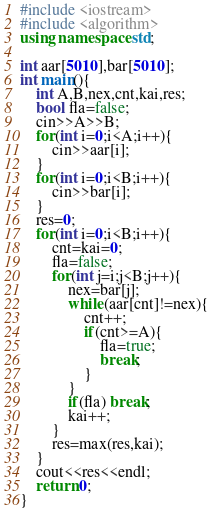Convert code to text. <code><loc_0><loc_0><loc_500><loc_500><_C++_>#include <iostream>
#include <algorithm>
using namespace std;

int aar[5010],bar[5010];
int main(){
	int A,B,nex,cnt,kai,res;
	bool fla=false;
	cin>>A>>B;
	for(int i=0;i<A;i++){
		cin>>aar[i];
	}
	for(int i=0;i<B;i++){
		cin>>bar[i];
	}
	res=0;
	for(int i=0;i<B;i++){
		cnt=kai=0;
		fla=false;
		for(int j=i;j<B;j++){
			nex=bar[j];
			while(aar[cnt]!=nex){
				cnt++;
				if(cnt>=A){
					fla=true;
					break;
				}
			}
			if(fla) break;
			kai++;
		}
		res=max(res,kai);
	}
	cout<<res<<endl;
	return 0;
}</code> 